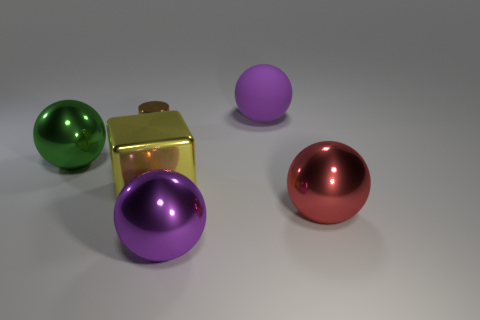Is there anything else that is the same shape as the small brown object?
Make the answer very short. No. There is a object that is the same color as the rubber sphere; what is it made of?
Give a very brief answer. Metal. Is the size of the green ball the same as the metal block?
Offer a very short reply. Yes. What number of objects are either large red metal spheres or big purple objects behind the red metal thing?
Provide a succinct answer. 2. What is the material of the green ball that is the same size as the yellow block?
Provide a succinct answer. Metal. There is a sphere that is to the right of the purple metal object and left of the large red object; what material is it?
Your response must be concise. Rubber. There is a metal object that is to the left of the cylinder; is there a brown cylinder that is in front of it?
Provide a succinct answer. No. There is a thing that is on the right side of the green thing and on the left side of the yellow object; how big is it?
Ensure brevity in your answer.  Small. How many green things are either big blocks or tiny rubber things?
Provide a short and direct response. 0. There is a yellow object that is the same size as the green sphere; what shape is it?
Ensure brevity in your answer.  Cube. 